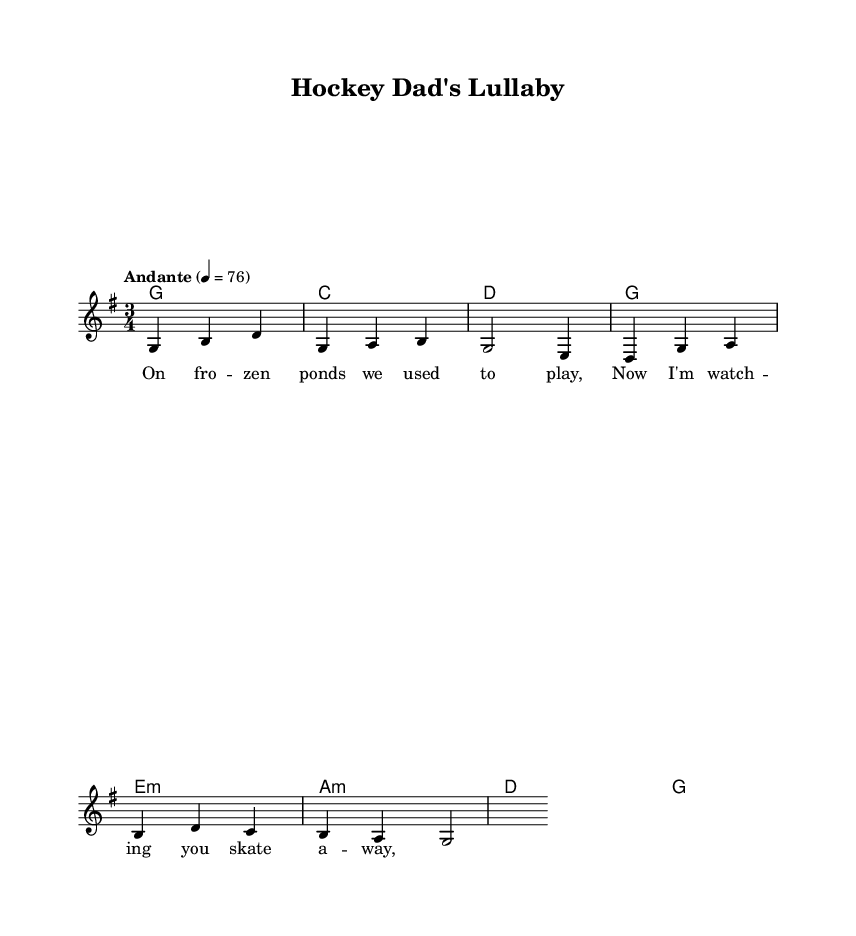What is the key signature of this music? The key signature shown in the music sheet indicates G major, which has one sharp (F#).
Answer: G major What is the time signature of this music? The time signature displayed in the sheet music is 3/4, meaning there are three beats in each measure.
Answer: 3/4 What is the tempo marking for this piece? The tempo marking specifies "Andante" at a metronome marking of quarter note = 76, suggesting a moderate walking pace.
Answer: Andante How many measures are in the melody? The melody section consists of eight measures, which is clear from the layout of the notes in the staff where the phrases conclude.
Answer: Eight Which chord follows G in the harmony? In the chord progression, after G, the next chord is C major, as indicated by the following symbol in the harmony line.
Answer: C What are the lyrics about? The lyrics reflect a nostalgic theme, portraying a parent watching their child skate, linking to memories of playing on frozen ponds.
Answer: Nostalgia What structure is commonly found in Canadian folk songs? The structure typically includes verses and a refrain, creating an engaging storytelling format, often focusing on themes like family and nature.
Answer: Verses and refrain 